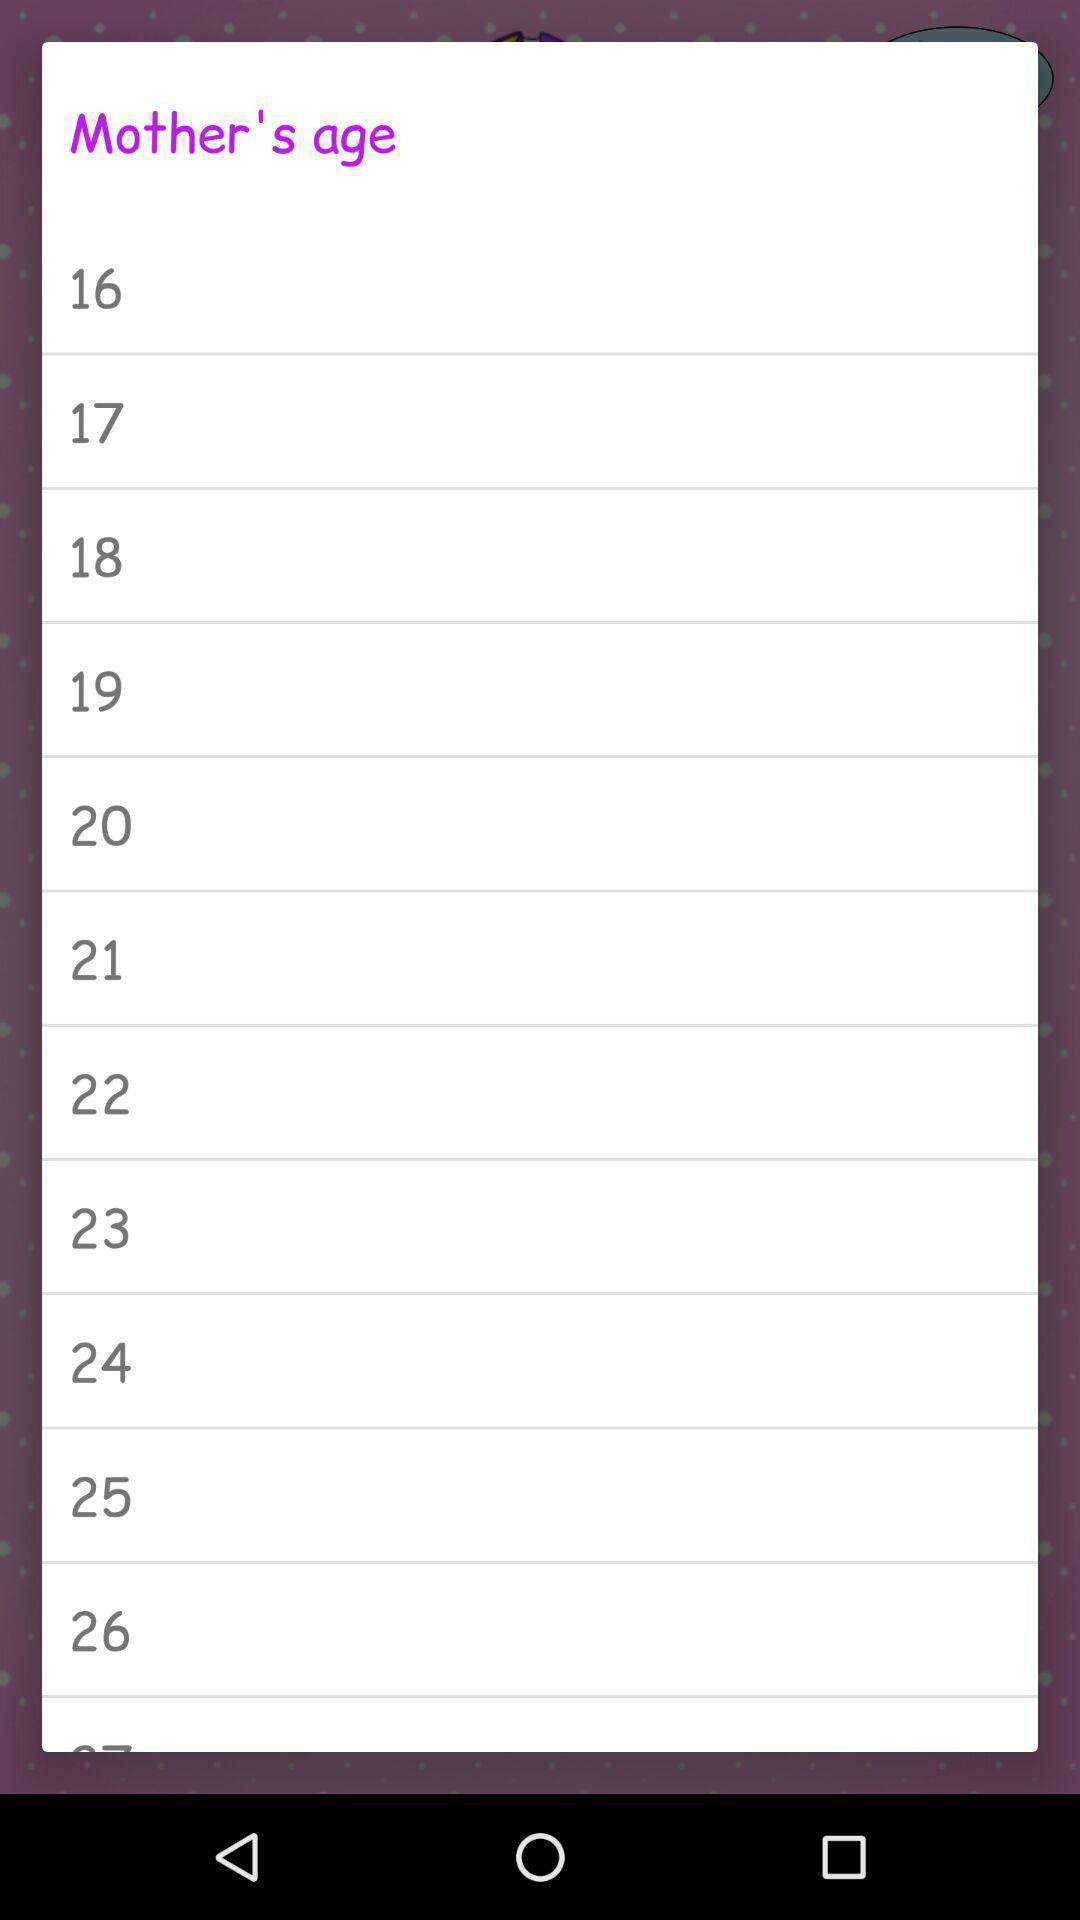Describe this image in words. Screen shows list of numbers of a person 's age. 